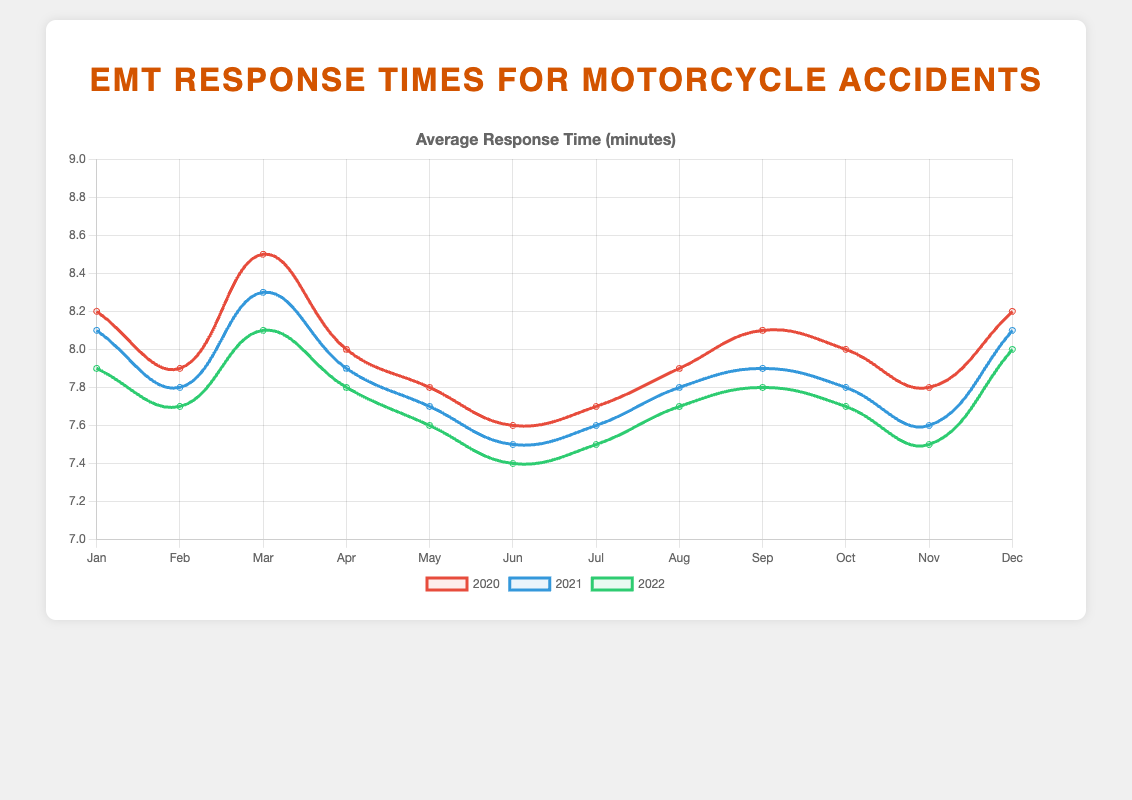What is the average response time in 2021? To find the average, we sum up the response times for all the months in 2021 and then divide by the number of months (12). The response times for 2021 are: 8.1 + 7.8 + 8.3 + 7.9 + 7.7 + 7.5 + 7.6 + 7.8 + 7.9 + 7.8 + 7.6 + 8.1 = 92.1. Thus, the average response time is 92.1 / 12 = 7.675
Answer: 7.675 In which year was the average response time the lowest? Compare the average response times for each year. For 2020: (8.2 + 7.9 + 8.5 + 8.0 + 7.8 + 7.6 + 7.7 + 7.9 + 8.1 + 8.0 + 7.8 + 8.2) / 12 = 7.9667. For 2021: 92.1 / 12 = 7.675. For 2022: (7.9 + 7.7 + 8.1 + 7.8 + 7.6 + 7.4 + 7.5 + 7.7 + 7.8 + 7.7 + 7.5 + 8.0) / 12 = 7.6833. The lowest average response time is in 2021, which is 7.675
Answer: 2021 Which month saw the highest response time in 2020? Look at the response times for each month in 2020. The month with the highest response time is March with 8.5 minutes
Answer: March Did the response time decrease or increase from June to July in 2022? Compare the response times for June (7.4) and July (7.5) in 2022. The response time increased from 7.4 to 7.5
Answer: Increased What is the overall trend of response times from January to December in 2020? By observing the line for 2020, there is an initial decrease from January to June, a slight increase in July, and then the response times remain fairly stable with minor fluctuations until December
Answer: Decrease, then stable Which year showed the most consistent response times throughout the months? To determine consistency, inspect the variability of the lines. The line for 2022 shows the least fluctuation in response times, ranging narrowly around 7.4 to 8.0
Answer: 2022 How much did the response time change in December from 2020 to 2022? Compare the response times in December 2020 (8.2) and December 2022 (8.0). The change is 8.2 - 8.0 = 0.2 minutes
Answer: 0.2 minutes In which month did response times see the same value across all three years? Find the month where the response times are equal for all years. There is no month where all three years have the same response time; all months show some variation
Answer: None 